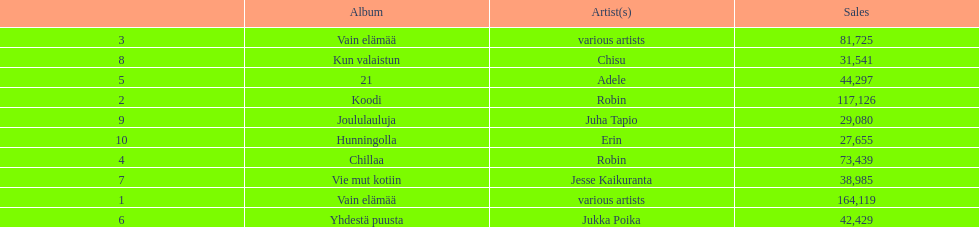Does adele or chisu have the highest number of sales? Adele. 